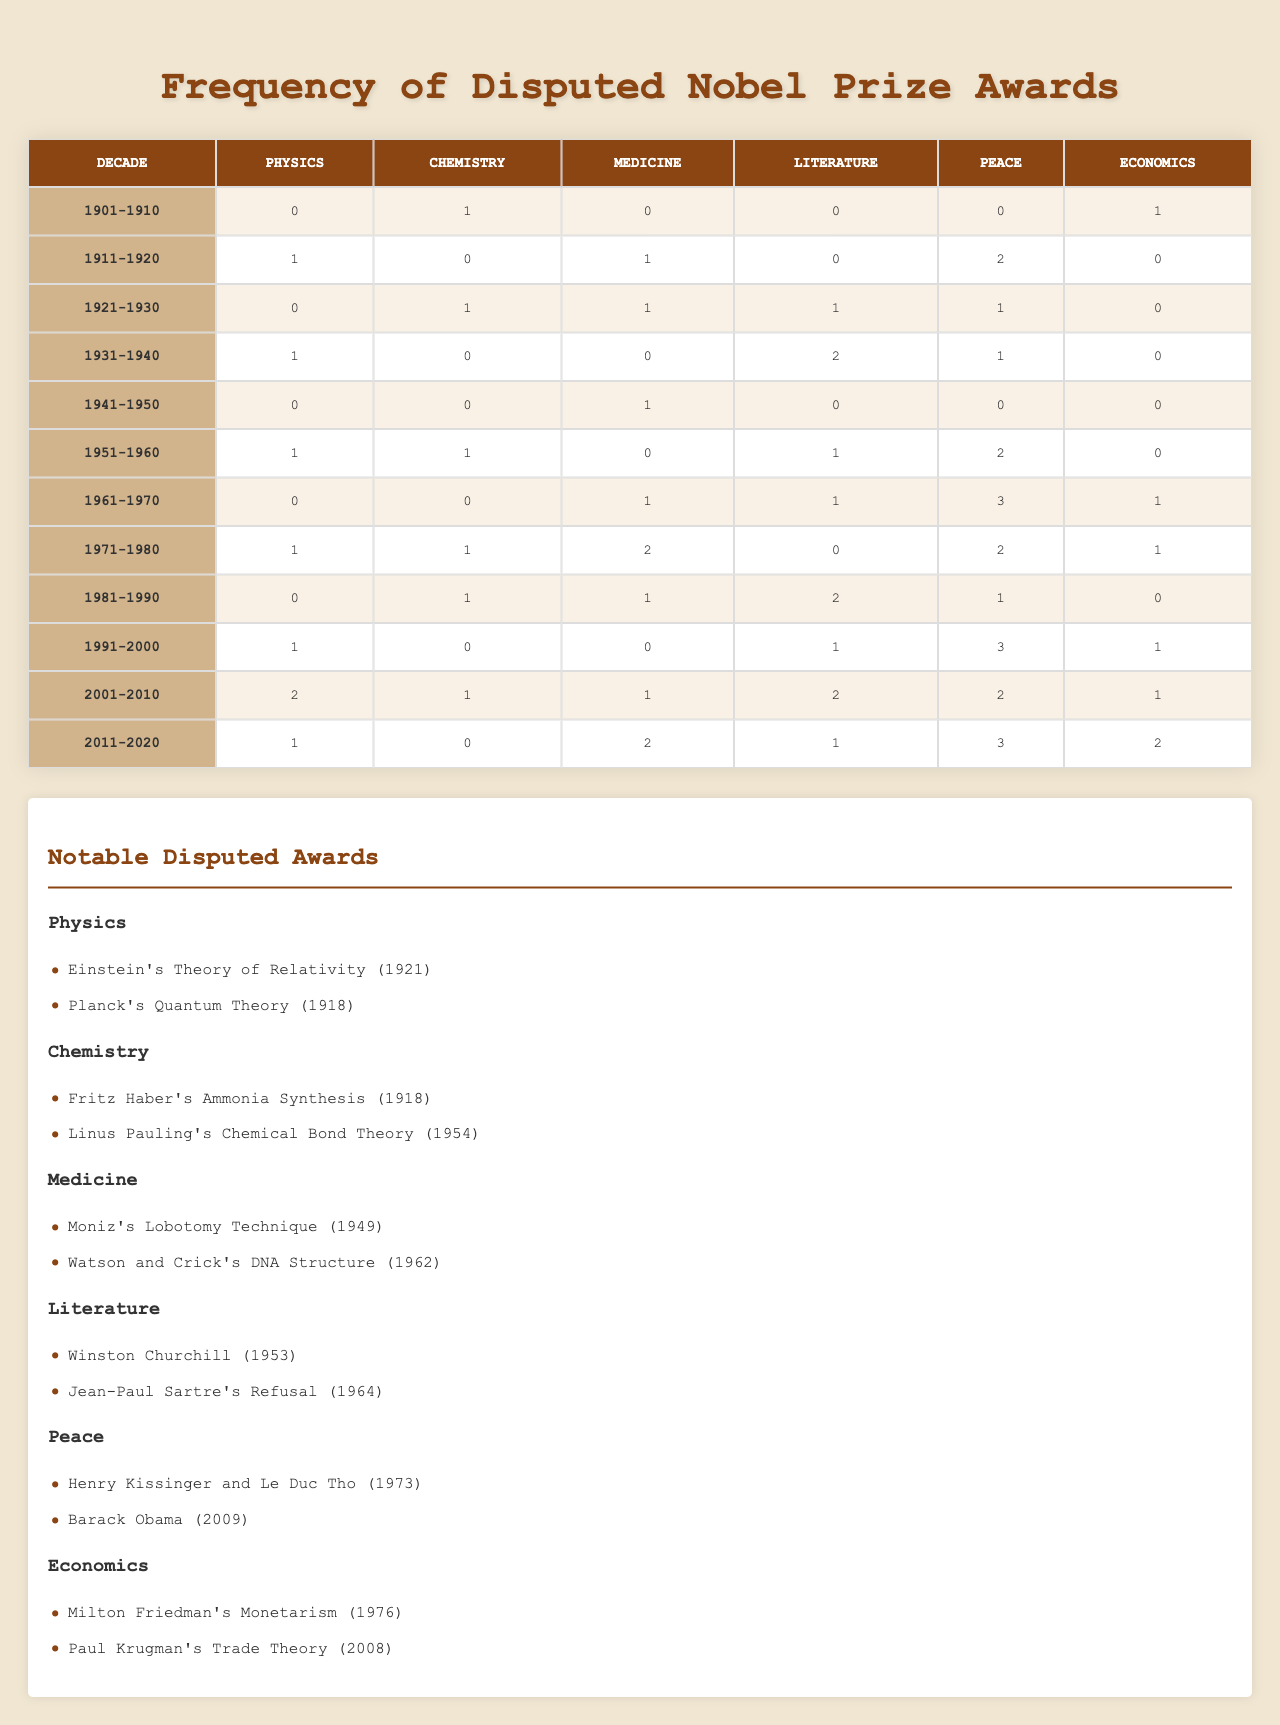What category had the highest number of disputed awards in the 1981-1990 decade? In the 1981-1990 decade, the highest number of disputed awards is found in the Literature category with 2 disputes, while other categories have either 1 or 0.
Answer: Literature How many disputed awards were there in total in the 1991-2000 decade? Summing the disputed awards in the 1991-2000 decade: Physics (1) + Chemistry (0) + Medicine (0) + Literature (1) + Peace (3) + Economics (1) = 6 total disputed awards.
Answer: 6 Was there a decade without any disputed awards in the Chemistry category? Looking at the data, the Chemistry category has 0 disputed awards in the decades of 1911-1920, 1941-1950, and 2001-2010, confirming there were decades without disputes.
Answer: Yes Which decade has the most disputed awards in the Peace category? In the Peace category, the highest number of disputed awards occurred in the 2001-2010 decade with 2 disputes. This is compared to other decades, which have lower numbers.
Answer: 2001-2010 What is the average number of disputed awards in the Medicine category across all decades? First, gather the data for Medicine: [0, 1, 1, 0, 1, 0, 1, 2, 1, 0, 1, 2]. The total is 10, and there are 12 decades, so the average is 10/12, which equals approximately 0.83.
Answer: 0.83 Which category had no disputed awards in the 1941-1950 decade? In the 1941-1950 decade, the categories Chemistry, Medicine, Literature, and Economics each had 0 disputed awards, confirmed by looking at each respective number for this decade.
Answer: Chemistry, Medicine, Literature, Economics How many more disputed awards were there in the Physics category than in the Economics category in the 1961-1970 decade? In the 1961-1970 decade, Physics had 1 disputed award while Economics had 3, so 1 - 3 = -2, thereby indicating Physics had 2 fewer disputes compared to Economics.
Answer: 2 fewer What is the relationship between the number of disputed awards in Literature and Peace in the decade of 2011-2020? In 2011-2020, Literature had 1 dispute while Peace had 3. The relationship indicates that Peace has more disputed awards, specifically 2 more than Literature in that decade.
Answer: Peace has 2 more disputes than Literature Identify the category with the fewest disputes across all decades. By reviewing the total disputes: Physics (6), Chemistry (5), Medicine (10), Literature (13), Peace (15), Economics (8), Chemistry has the fewest total disputes with 5 awarded in total.
Answer: Chemistry In which decade did disputed awards peak for the Peace category and by how much compared to the previous decade? The Peace category peaked in the 1991-2000 decade with 3 disputed awards, compared to the 1981-1990 decade, which had 2, indicating an increase of 1.
Answer: 1991-2000, increase of 1 